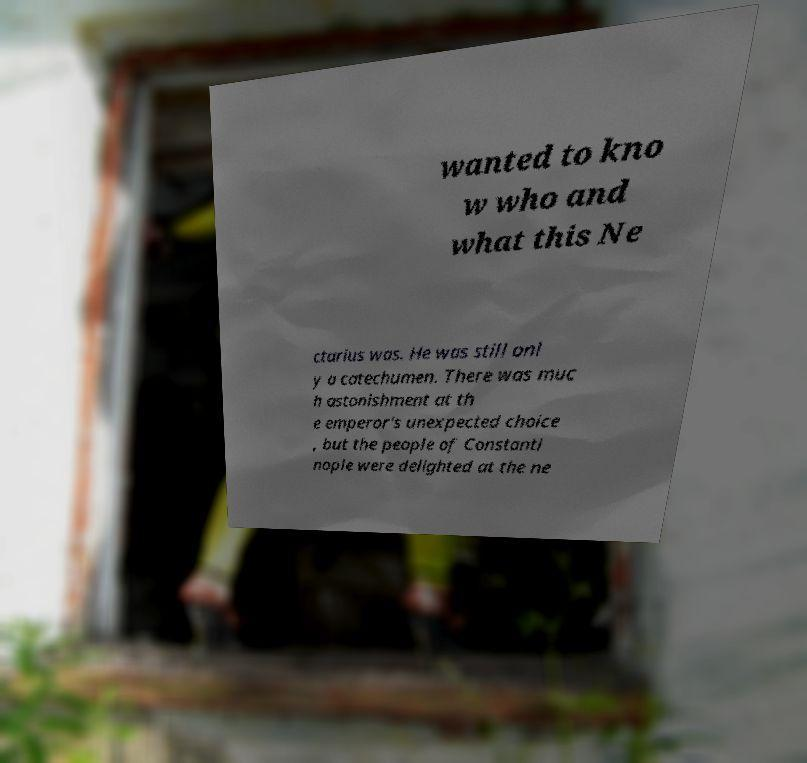Could you extract and type out the text from this image? wanted to kno w who and what this Ne ctarius was. He was still onl y a catechumen. There was muc h astonishment at th e emperor's unexpected choice , but the people of Constanti nople were delighted at the ne 